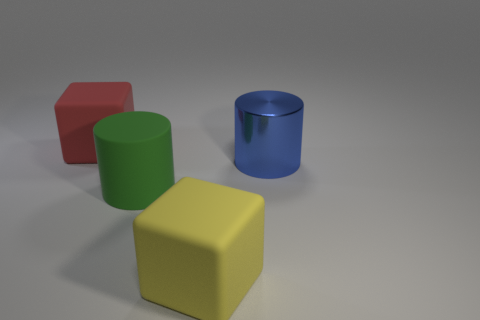Add 2 big green rubber objects. How many objects exist? 6 Subtract all matte things. Subtract all big yellow matte cubes. How many objects are left? 0 Add 2 big blue shiny cylinders. How many big blue shiny cylinders are left? 3 Add 4 big red matte things. How many big red matte things exist? 5 Subtract 0 purple balls. How many objects are left? 4 